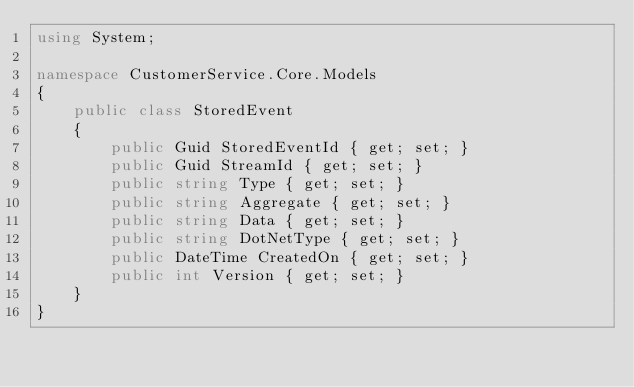<code> <loc_0><loc_0><loc_500><loc_500><_C#_>using System;

namespace CustomerService.Core.Models
{
    public class StoredEvent
    {
        public Guid StoredEventId { get; set; }
        public Guid StreamId { get; set; }
        public string Type { get; set; }
        public string Aggregate { get; set; }
        public string Data { get; set; }
        public string DotNetType { get; set; }
        public DateTime CreatedOn { get; set; }
        public int Version { get; set; }
    }
}
</code> 